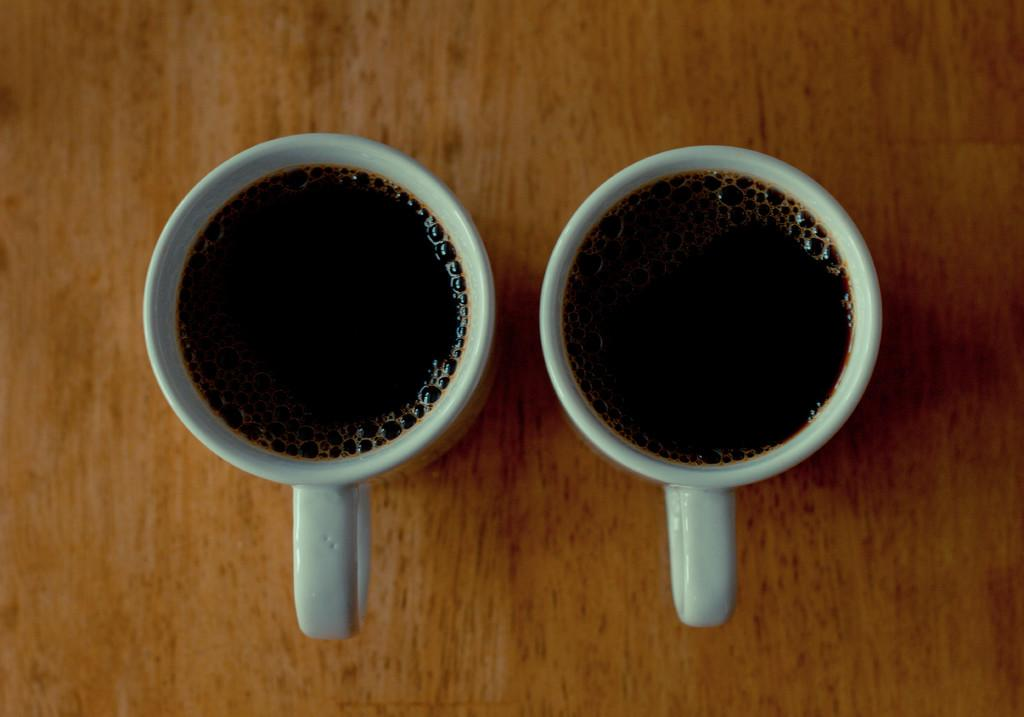How many cups are visible in the image? There are two cups in the image. What is inside the cups? The cups contain liquid. Where are the cups placed? The cups are on a platform. What type of pies are being held by the hand in the image? There is no hand or pies present in the image. What is the stem used for in the image? There is no stem present in the image. 